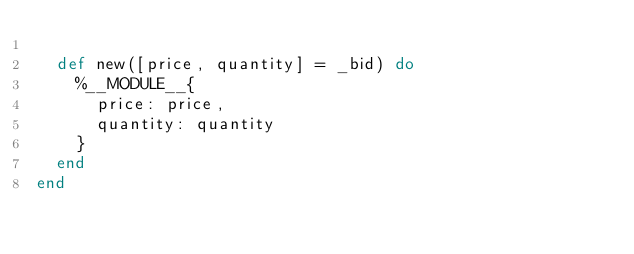Convert code to text. <code><loc_0><loc_0><loc_500><loc_500><_Elixir_>
  def new([price, quantity] = _bid) do
    %__MODULE__{
      price: price,
      quantity: quantity
    }
  end
end
</code> 